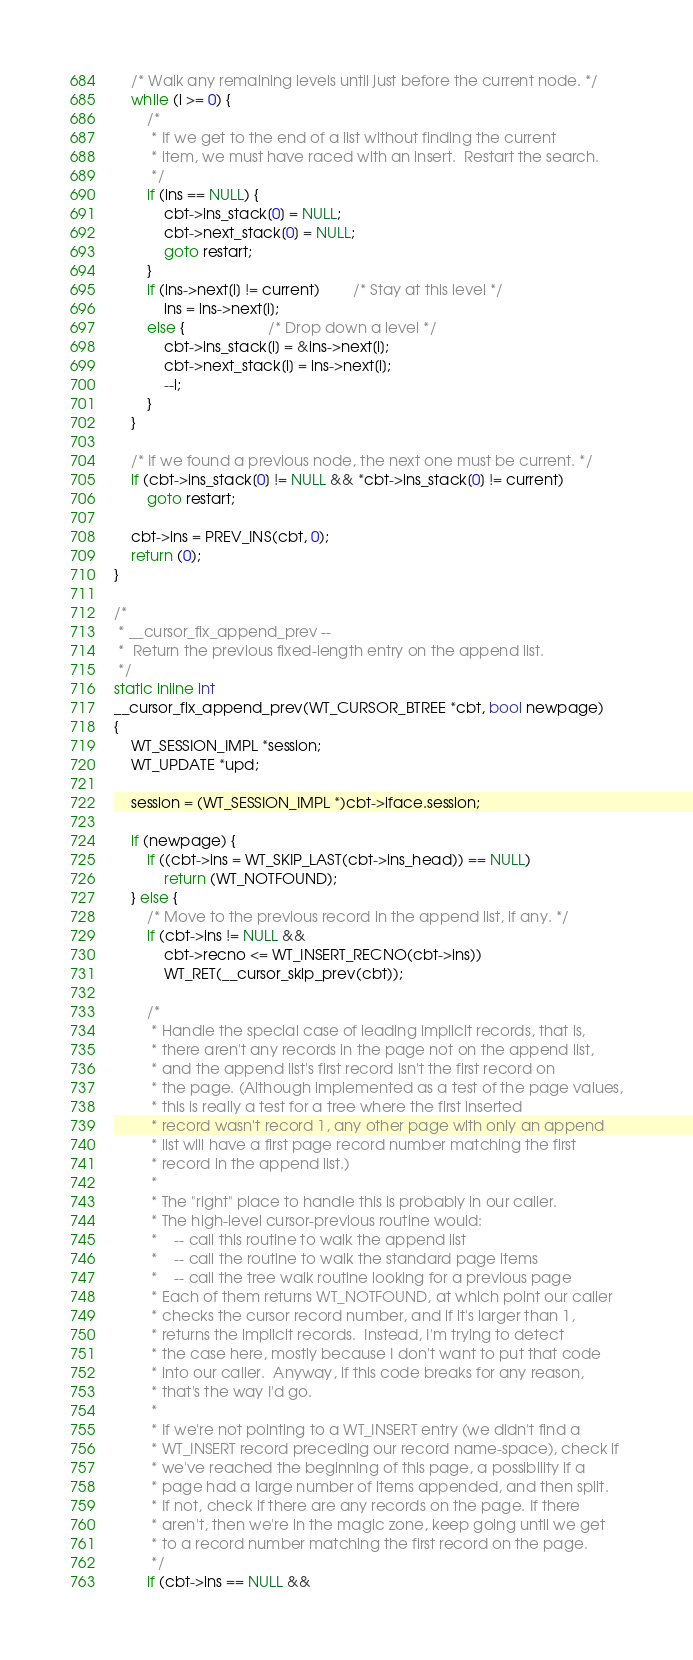Convert code to text. <code><loc_0><loc_0><loc_500><loc_500><_C_>
	/* Walk any remaining levels until just before the current node. */
	while (i >= 0) {
		/*
		 * If we get to the end of a list without finding the current
		 * item, we must have raced with an insert.  Restart the search.
		 */
		if (ins == NULL) {
			cbt->ins_stack[0] = NULL;
			cbt->next_stack[0] = NULL;
			goto restart;
		}
		if (ins->next[i] != current)		/* Stay at this level */
			ins = ins->next[i];
		else {					/* Drop down a level */
			cbt->ins_stack[i] = &ins->next[i];
			cbt->next_stack[i] = ins->next[i];
			--i;
		}
	}

	/* If we found a previous node, the next one must be current. */
	if (cbt->ins_stack[0] != NULL && *cbt->ins_stack[0] != current)
		goto restart;

	cbt->ins = PREV_INS(cbt, 0);
	return (0);
}

/*
 * __cursor_fix_append_prev --
 *	Return the previous fixed-length entry on the append list.
 */
static inline int
__cursor_fix_append_prev(WT_CURSOR_BTREE *cbt, bool newpage)
{
	WT_SESSION_IMPL *session;
	WT_UPDATE *upd;

	session = (WT_SESSION_IMPL *)cbt->iface.session;

	if (newpage) {
		if ((cbt->ins = WT_SKIP_LAST(cbt->ins_head)) == NULL)
			return (WT_NOTFOUND);
	} else {
		/* Move to the previous record in the append list, if any. */
		if (cbt->ins != NULL &&
		    cbt->recno <= WT_INSERT_RECNO(cbt->ins))
			WT_RET(__cursor_skip_prev(cbt));

		/*
		 * Handle the special case of leading implicit records, that is,
		 * there aren't any records in the page not on the append list,
		 * and the append list's first record isn't the first record on
		 * the page. (Although implemented as a test of the page values,
		 * this is really a test for a tree where the first inserted
		 * record wasn't record 1, any other page with only an append
		 * list will have a first page record number matching the first
		 * record in the append list.)
		 *
		 * The "right" place to handle this is probably in our caller.
		 * The high-level cursor-previous routine would:
		 *    -- call this routine to walk the append list
		 *    -- call the routine to walk the standard page items
		 *    -- call the tree walk routine looking for a previous page
		 * Each of them returns WT_NOTFOUND, at which point our caller
		 * checks the cursor record number, and if it's larger than 1,
		 * returns the implicit records.  Instead, I'm trying to detect
		 * the case here, mostly because I don't want to put that code
		 * into our caller.  Anyway, if this code breaks for any reason,
		 * that's the way I'd go.
		 *
		 * If we're not pointing to a WT_INSERT entry (we didn't find a
		 * WT_INSERT record preceding our record name-space), check if
		 * we've reached the beginning of this page, a possibility if a
		 * page had a large number of items appended, and then split.
		 * If not, check if there are any records on the page. If there
		 * aren't, then we're in the magic zone, keep going until we get
		 * to a record number matching the first record on the page.
		 */
		if (cbt->ins == NULL &&</code> 